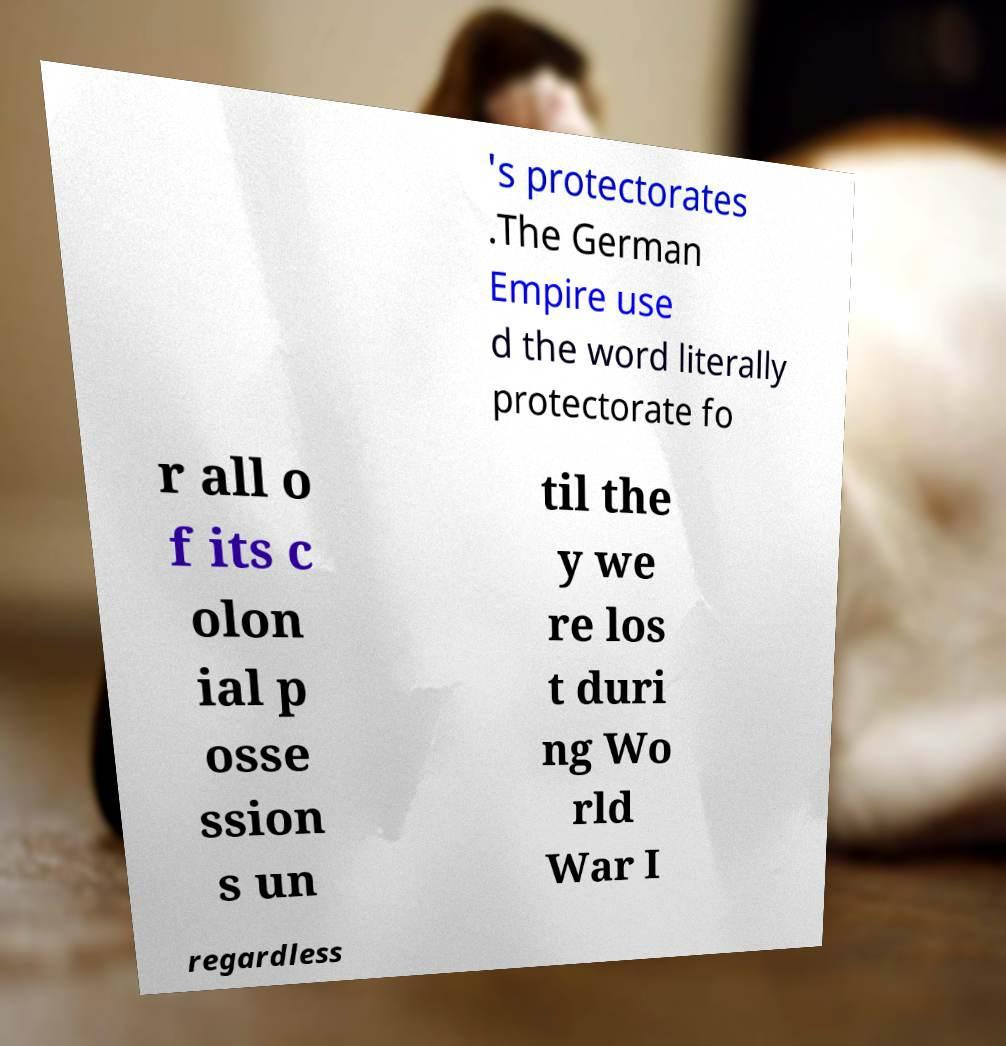For documentation purposes, I need the text within this image transcribed. Could you provide that? 's protectorates .The German Empire use d the word literally protectorate fo r all o f its c olon ial p osse ssion s un til the y we re los t duri ng Wo rld War I regardless 